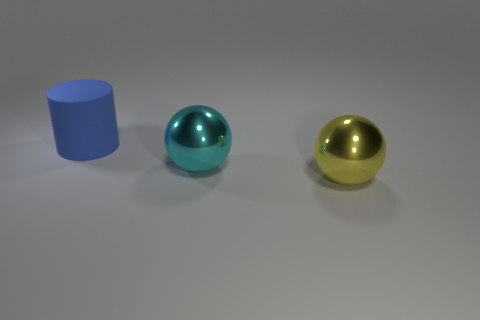Is there any other thing that has the same shape as the rubber thing?
Your response must be concise. No. What is the yellow ball made of?
Make the answer very short. Metal. There is a large object that is left of the cyan ball; how many large cylinders are behind it?
Provide a short and direct response. 0. Do the large metallic object behind the big yellow metallic thing and the large object that is on the left side of the big cyan sphere have the same shape?
Make the answer very short. No. What number of big objects are behind the cyan shiny thing and in front of the big blue rubber thing?
Your answer should be very brief. 0. Are there any big shiny spheres that have the same color as the big matte cylinder?
Your answer should be very brief. No. The yellow metallic object that is the same size as the matte thing is what shape?
Provide a short and direct response. Sphere. There is a large blue cylinder; are there any metal balls on the left side of it?
Ensure brevity in your answer.  No. Is the large blue thing that is to the left of the big cyan metal object made of the same material as the big ball to the right of the cyan ball?
Provide a short and direct response. No. What number of spheres are the same size as the blue matte object?
Your response must be concise. 2. 